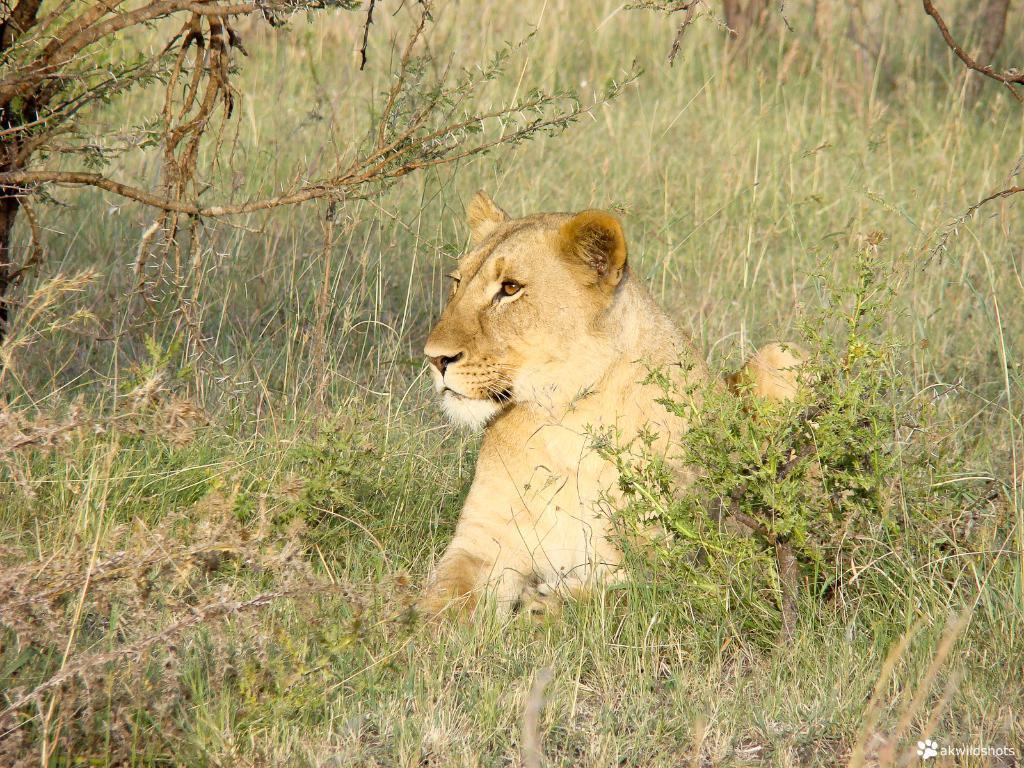Could you give a brief overview of what you see in this image? In this image I can see an animal which is in brown and white color. It is on the grass. In the background I can see few plants. 